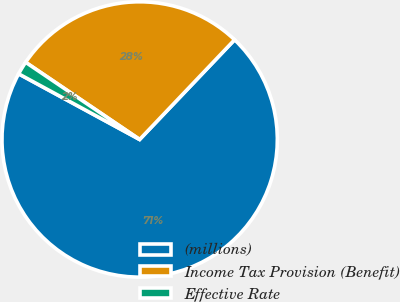Convert chart. <chart><loc_0><loc_0><loc_500><loc_500><pie_chart><fcel>(millions)<fcel>Income Tax Provision (Benefit)<fcel>Effective Rate<nl><fcel>70.8%<fcel>27.64%<fcel>1.56%<nl></chart> 